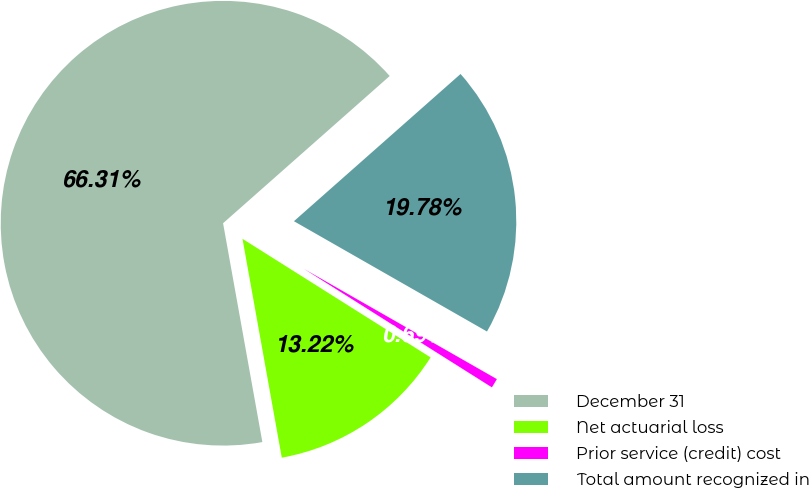<chart> <loc_0><loc_0><loc_500><loc_500><pie_chart><fcel>December 31<fcel>Net actuarial loss<fcel>Prior service (credit) cost<fcel>Total amount recognized in<nl><fcel>66.31%<fcel>13.22%<fcel>0.69%<fcel>19.78%<nl></chart> 